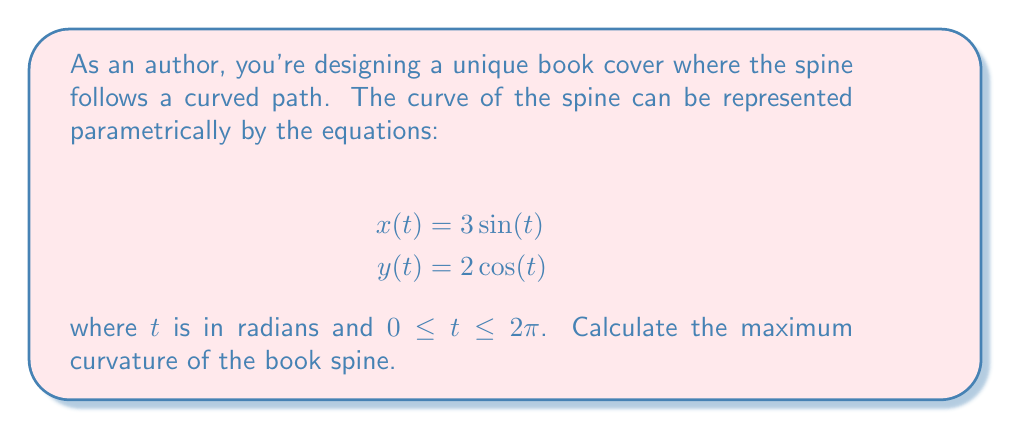Solve this math problem. To find the maximum curvature of the book spine, we'll follow these steps:

1) The curvature $\kappa$ of a curve given by parametric equations is:

   $$\kappa = \frac{|x'y'' - y'x''|}{(x'^2 + y'^2)^{3/2}}$$

2) Let's calculate the first and second derivatives:
   
   $x' = 3\cos(t)$, $x'' = -3\sin(t)$
   $y' = -2\sin(t)$, $y'' = -2\cos(t)$

3) Substituting these into the curvature formula:

   $$\kappa = \frac{|3\cos(t)(-2\cos(t)) - (-2\sin(t))(-3\sin(t))|}{(9\cos^2(t) + 4\sin^2(t))^{3/2}}$$

4) Simplifying:

   $$\kappa = \frac{|-6\cos^2(t) - 6\sin^2(t)|}{(9\cos^2(t) + 4\sin^2(t))^{3/2}} = \frac{6}{(9\cos^2(t) + 4\sin^2(t))^{3/2}}$$

5) To find the maximum curvature, we need to minimize the denominator. The denominator is minimized when $\cos^2(t)$ is at its minimum (0) and $\sin^2(t)$ is at its maximum (1), or vice versa.

6) The minimum value of the denominator is:

   $$(4)^{3/2} = 8$$

7) Therefore, the maximum curvature is:

   $$\kappa_{max} = \frac{6}{8} = \frac{3}{4}$$
Answer: The maximum curvature of the book spine is $\frac{3}{4}$. 